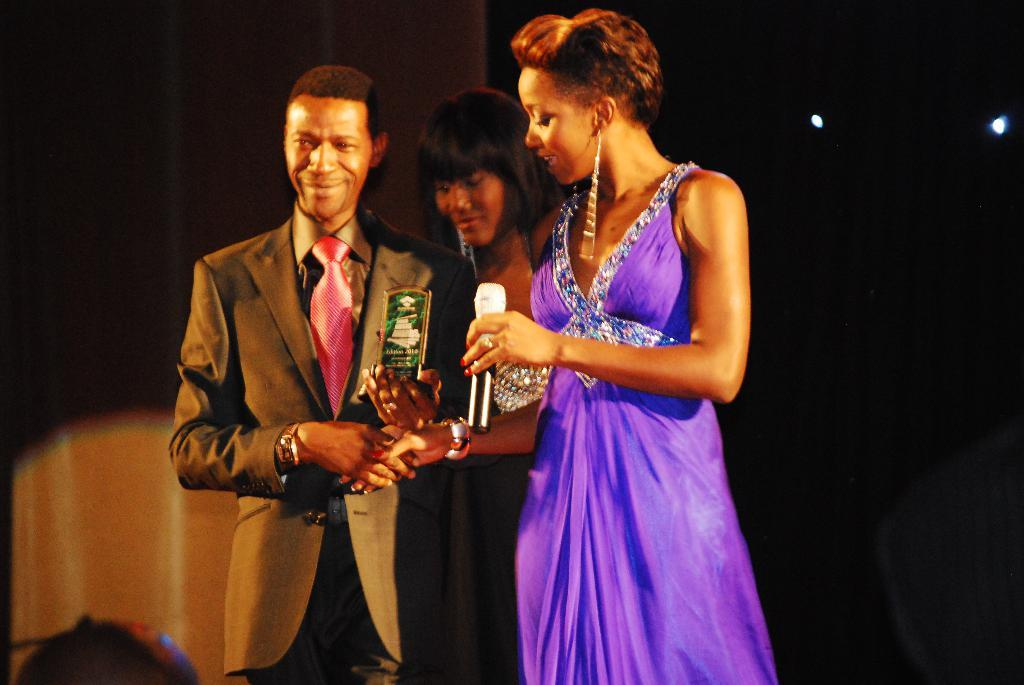How many people are in the image? There are three people standing in the image. What are the people holding in the image? One person is holding a trophy, and another person is holding a microphone. What is the color of the background in the image? The background of the image is dark. What can be seen in the background of the image? There are lights visible in the background. What type of beast is present in the image? There is no beast present in the image; it features three people, one holding a trophy and another holding a microphone. What type of secretary can be seen in the image? There is no secretary present in the image. 